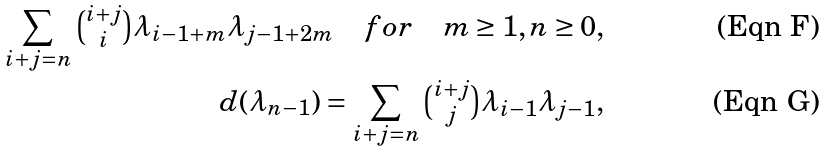Convert formula to latex. <formula><loc_0><loc_0><loc_500><loc_500>\sum _ { i + j = n } \tbinom { i + j } { i } \lambda _ { i - 1 + m } \lambda _ { j - 1 + 2 m } \quad f o r \quad m \geq 1 , n \geq 0 , \\ d ( \lambda _ { n - 1 } ) = \sum _ { i + j = n } \tbinom { i + j } { j } \lambda _ { i - 1 } \lambda _ { j - 1 } ,</formula> 